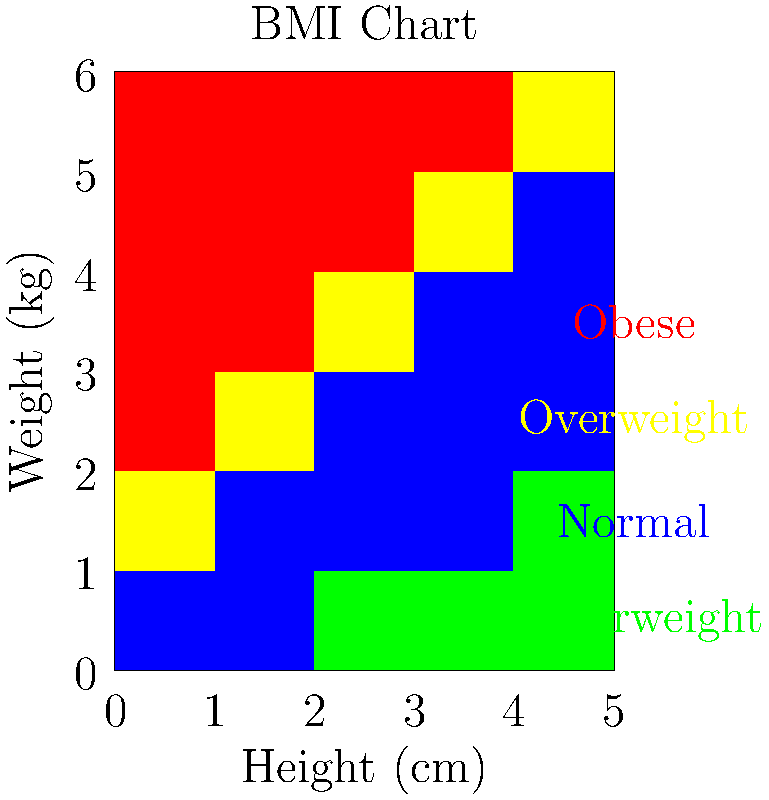Using the BMI chart provided, what is the BMI category for a person who is 170 cm tall and weighs 80 kg? Additionally, calculate their exact BMI to two decimal places. To solve this problem, we'll follow these steps:

1. Locate the person's height and weight on the chart:
   Height: 170 cm
   Weight: 80 kg

2. Find the intersection of these values on the chart. We can see that it falls in the yellow region, which corresponds to the "Overweight" category.

3. To calculate the exact BMI, we'll use the formula:
   $$ \text{BMI} = \frac{\text{weight (kg)}}{\text{height (m)}^2} $$

4. Convert height from cm to m:
   $$ 170 \text{ cm} = 1.70 \text{ m} $$

5. Plug the values into the formula:
   $$ \text{BMI} = \frac{80}{1.70^2} = \frac{80}{2.89} \approx 27.68 $$

6. Round the result to two decimal places: 27.68

The calculated BMI of 27.68 confirms that the person falls into the "Overweight" category (25.0 to 29.9).
Answer: Overweight; BMI = 27.68 